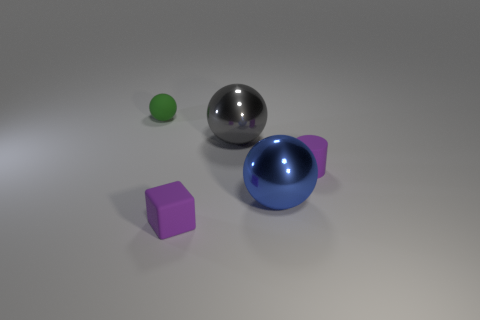Add 3 tiny purple blocks. How many objects exist? 8 Subtract all cylinders. How many objects are left? 4 Subtract 1 blue balls. How many objects are left? 4 Subtract all big gray balls. Subtract all big blue objects. How many objects are left? 3 Add 4 large blue metallic objects. How many large blue metallic objects are left? 5 Add 3 small red cylinders. How many small red cylinders exist? 3 